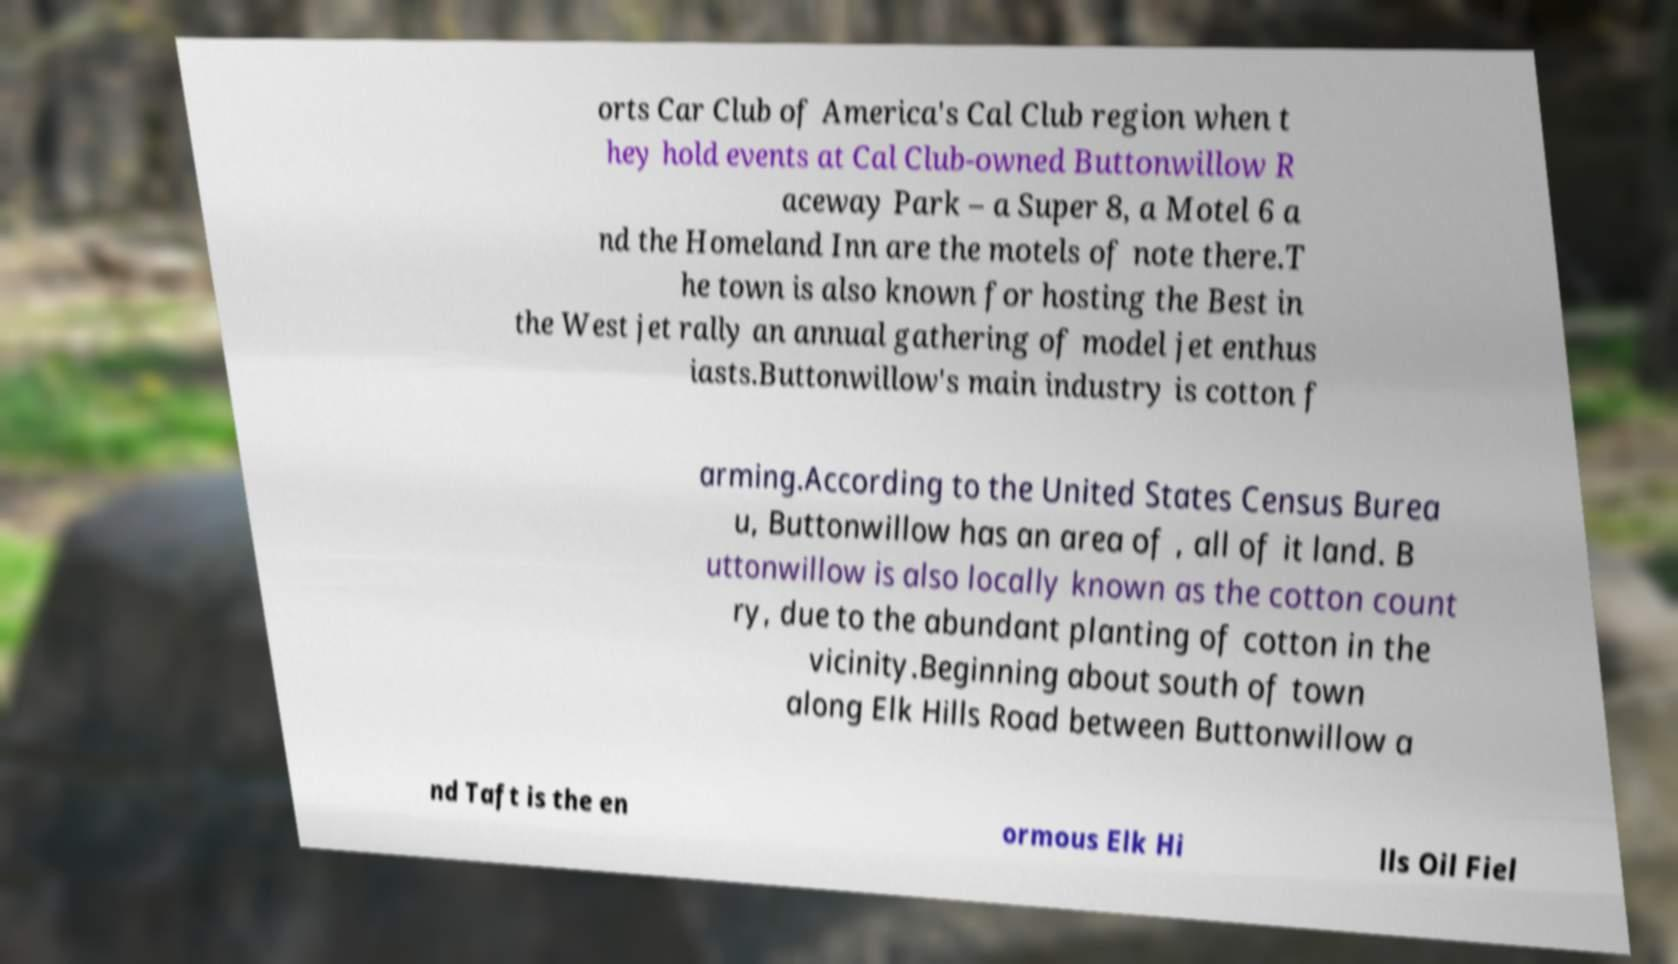Please identify and transcribe the text found in this image. orts Car Club of America's Cal Club region when t hey hold events at Cal Club-owned Buttonwillow R aceway Park – a Super 8, a Motel 6 a nd the Homeland Inn are the motels of note there.T he town is also known for hosting the Best in the West jet rally an annual gathering of model jet enthus iasts.Buttonwillow's main industry is cotton f arming.According to the United States Census Burea u, Buttonwillow has an area of , all of it land. B uttonwillow is also locally known as the cotton count ry, due to the abundant planting of cotton in the vicinity.Beginning about south of town along Elk Hills Road between Buttonwillow a nd Taft is the en ormous Elk Hi lls Oil Fiel 